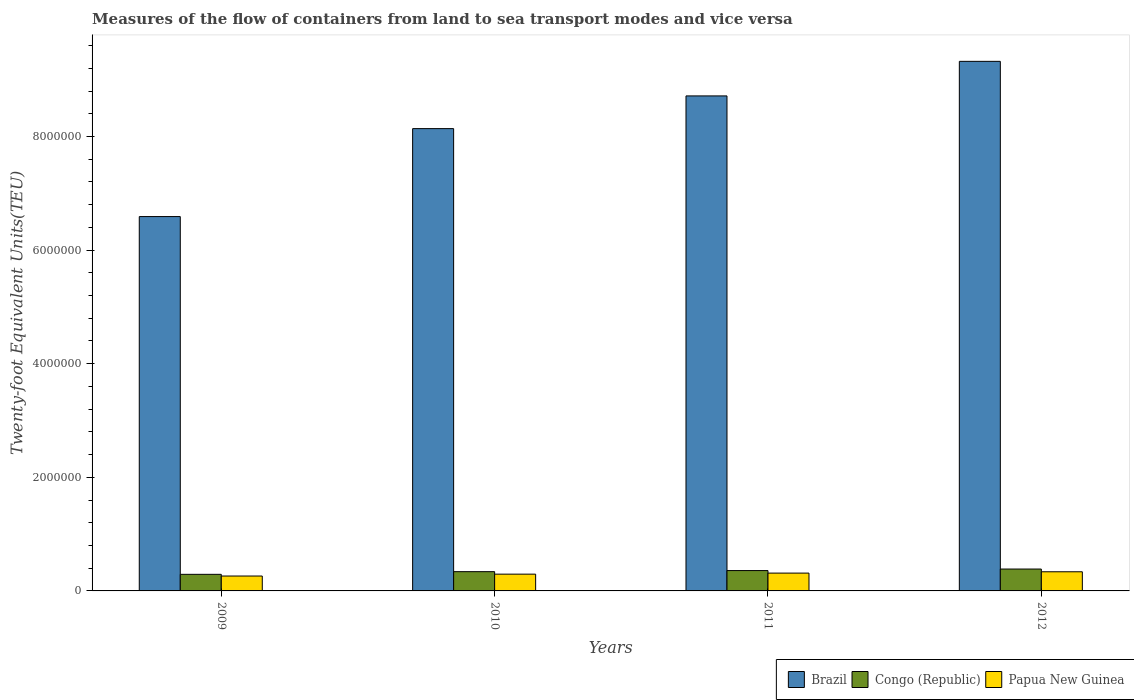How many bars are there on the 1st tick from the left?
Your response must be concise. 3. How many bars are there on the 3rd tick from the right?
Ensure brevity in your answer.  3. What is the label of the 2nd group of bars from the left?
Make the answer very short. 2010. What is the container port traffic in Congo (Republic) in 2009?
Provide a short and direct response. 2.92e+05. Across all years, what is the maximum container port traffic in Congo (Republic)?
Your answer should be compact. 3.85e+05. Across all years, what is the minimum container port traffic in Papua New Guinea?
Keep it short and to the point. 2.62e+05. What is the total container port traffic in Papua New Guinea in the graph?
Offer a terse response. 1.21e+06. What is the difference between the container port traffic in Papua New Guinea in 2010 and that in 2012?
Offer a terse response. -4.18e+04. What is the difference between the container port traffic in Brazil in 2011 and the container port traffic in Congo (Republic) in 2012?
Give a very brief answer. 8.33e+06. What is the average container port traffic in Papua New Guinea per year?
Offer a very short reply. 3.02e+05. In the year 2011, what is the difference between the container port traffic in Brazil and container port traffic in Congo (Republic)?
Offer a terse response. 8.36e+06. In how many years, is the container port traffic in Brazil greater than 2000000 TEU?
Provide a short and direct response. 4. What is the ratio of the container port traffic in Congo (Republic) in 2010 to that in 2011?
Your answer should be compact. 0.95. Is the container port traffic in Papua New Guinea in 2009 less than that in 2012?
Give a very brief answer. Yes. What is the difference between the highest and the second highest container port traffic in Brazil?
Ensure brevity in your answer.  6.08e+05. What is the difference between the highest and the lowest container port traffic in Congo (Republic)?
Offer a very short reply. 9.32e+04. Is the sum of the container port traffic in Papua New Guinea in 2011 and 2012 greater than the maximum container port traffic in Brazil across all years?
Your response must be concise. No. What does the 1st bar from the left in 2012 represents?
Give a very brief answer. Brazil. What does the 1st bar from the right in 2009 represents?
Give a very brief answer. Papua New Guinea. Is it the case that in every year, the sum of the container port traffic in Brazil and container port traffic in Papua New Guinea is greater than the container port traffic in Congo (Republic)?
Offer a very short reply. Yes. How many bars are there?
Offer a terse response. 12. What is the difference between two consecutive major ticks on the Y-axis?
Your answer should be very brief. 2.00e+06. How many legend labels are there?
Give a very brief answer. 3. What is the title of the graph?
Provide a succinct answer. Measures of the flow of containers from land to sea transport modes and vice versa. What is the label or title of the Y-axis?
Offer a terse response. Twenty-foot Equivalent Units(TEU). What is the Twenty-foot Equivalent Units(TEU) of Brazil in 2009?
Make the answer very short. 6.59e+06. What is the Twenty-foot Equivalent Units(TEU) of Congo (Republic) in 2009?
Your answer should be very brief. 2.92e+05. What is the Twenty-foot Equivalent Units(TEU) of Papua New Guinea in 2009?
Make the answer very short. 2.62e+05. What is the Twenty-foot Equivalent Units(TEU) in Brazil in 2010?
Ensure brevity in your answer.  8.14e+06. What is the Twenty-foot Equivalent Units(TEU) of Congo (Republic) in 2010?
Your answer should be compact. 3.39e+05. What is the Twenty-foot Equivalent Units(TEU) of Papua New Guinea in 2010?
Give a very brief answer. 2.95e+05. What is the Twenty-foot Equivalent Units(TEU) of Brazil in 2011?
Give a very brief answer. 8.71e+06. What is the Twenty-foot Equivalent Units(TEU) of Congo (Republic) in 2011?
Ensure brevity in your answer.  3.58e+05. What is the Twenty-foot Equivalent Units(TEU) in Papua New Guinea in 2011?
Provide a short and direct response. 3.14e+05. What is the Twenty-foot Equivalent Units(TEU) of Brazil in 2012?
Your answer should be compact. 9.32e+06. What is the Twenty-foot Equivalent Units(TEU) of Congo (Republic) in 2012?
Provide a succinct answer. 3.85e+05. What is the Twenty-foot Equivalent Units(TEU) of Papua New Guinea in 2012?
Make the answer very short. 3.37e+05. Across all years, what is the maximum Twenty-foot Equivalent Units(TEU) of Brazil?
Make the answer very short. 9.32e+06. Across all years, what is the maximum Twenty-foot Equivalent Units(TEU) in Congo (Republic)?
Keep it short and to the point. 3.85e+05. Across all years, what is the maximum Twenty-foot Equivalent Units(TEU) in Papua New Guinea?
Your answer should be very brief. 3.37e+05. Across all years, what is the minimum Twenty-foot Equivalent Units(TEU) in Brazil?
Make the answer very short. 6.59e+06. Across all years, what is the minimum Twenty-foot Equivalent Units(TEU) in Congo (Republic)?
Your response must be concise. 2.92e+05. Across all years, what is the minimum Twenty-foot Equivalent Units(TEU) of Papua New Guinea?
Your answer should be very brief. 2.62e+05. What is the total Twenty-foot Equivalent Units(TEU) in Brazil in the graph?
Keep it short and to the point. 3.28e+07. What is the total Twenty-foot Equivalent Units(TEU) in Congo (Republic) in the graph?
Provide a short and direct response. 1.37e+06. What is the total Twenty-foot Equivalent Units(TEU) of Papua New Guinea in the graph?
Give a very brief answer. 1.21e+06. What is the difference between the Twenty-foot Equivalent Units(TEU) of Brazil in 2009 and that in 2010?
Offer a very short reply. -1.55e+06. What is the difference between the Twenty-foot Equivalent Units(TEU) of Congo (Republic) in 2009 and that in 2010?
Provide a short and direct response. -4.70e+04. What is the difference between the Twenty-foot Equivalent Units(TEU) in Papua New Guinea in 2009 and that in 2010?
Provide a short and direct response. -3.31e+04. What is the difference between the Twenty-foot Equivalent Units(TEU) in Brazil in 2009 and that in 2011?
Your answer should be very brief. -2.12e+06. What is the difference between the Twenty-foot Equivalent Units(TEU) of Congo (Republic) in 2009 and that in 2011?
Provide a short and direct response. -6.63e+04. What is the difference between the Twenty-foot Equivalent Units(TEU) of Papua New Guinea in 2009 and that in 2011?
Offer a terse response. -5.14e+04. What is the difference between the Twenty-foot Equivalent Units(TEU) of Brazil in 2009 and that in 2012?
Give a very brief answer. -2.73e+06. What is the difference between the Twenty-foot Equivalent Units(TEU) of Congo (Republic) in 2009 and that in 2012?
Ensure brevity in your answer.  -9.32e+04. What is the difference between the Twenty-foot Equivalent Units(TEU) of Papua New Guinea in 2009 and that in 2012?
Offer a very short reply. -7.49e+04. What is the difference between the Twenty-foot Equivalent Units(TEU) of Brazil in 2010 and that in 2011?
Make the answer very short. -5.76e+05. What is the difference between the Twenty-foot Equivalent Units(TEU) of Congo (Republic) in 2010 and that in 2011?
Your response must be concise. -1.93e+04. What is the difference between the Twenty-foot Equivalent Units(TEU) of Papua New Guinea in 2010 and that in 2011?
Offer a very short reply. -1.83e+04. What is the difference between the Twenty-foot Equivalent Units(TEU) in Brazil in 2010 and that in 2012?
Offer a very short reply. -1.18e+06. What is the difference between the Twenty-foot Equivalent Units(TEU) in Congo (Republic) in 2010 and that in 2012?
Keep it short and to the point. -4.62e+04. What is the difference between the Twenty-foot Equivalent Units(TEU) of Papua New Guinea in 2010 and that in 2012?
Offer a terse response. -4.18e+04. What is the difference between the Twenty-foot Equivalent Units(TEU) of Brazil in 2011 and that in 2012?
Ensure brevity in your answer.  -6.08e+05. What is the difference between the Twenty-foot Equivalent Units(TEU) in Congo (Republic) in 2011 and that in 2012?
Offer a terse response. -2.69e+04. What is the difference between the Twenty-foot Equivalent Units(TEU) of Papua New Guinea in 2011 and that in 2012?
Your answer should be very brief. -2.35e+04. What is the difference between the Twenty-foot Equivalent Units(TEU) of Brazil in 2009 and the Twenty-foot Equivalent Units(TEU) of Congo (Republic) in 2010?
Your answer should be very brief. 6.25e+06. What is the difference between the Twenty-foot Equivalent Units(TEU) in Brazil in 2009 and the Twenty-foot Equivalent Units(TEU) in Papua New Guinea in 2010?
Your response must be concise. 6.30e+06. What is the difference between the Twenty-foot Equivalent Units(TEU) of Congo (Republic) in 2009 and the Twenty-foot Equivalent Units(TEU) of Papua New Guinea in 2010?
Keep it short and to the point. -3368.95. What is the difference between the Twenty-foot Equivalent Units(TEU) in Brazil in 2009 and the Twenty-foot Equivalent Units(TEU) in Congo (Republic) in 2011?
Make the answer very short. 6.23e+06. What is the difference between the Twenty-foot Equivalent Units(TEU) in Brazil in 2009 and the Twenty-foot Equivalent Units(TEU) in Papua New Guinea in 2011?
Offer a terse response. 6.28e+06. What is the difference between the Twenty-foot Equivalent Units(TEU) in Congo (Republic) in 2009 and the Twenty-foot Equivalent Units(TEU) in Papua New Guinea in 2011?
Your answer should be compact. -2.17e+04. What is the difference between the Twenty-foot Equivalent Units(TEU) of Brazil in 2009 and the Twenty-foot Equivalent Units(TEU) of Congo (Republic) in 2012?
Provide a short and direct response. 6.21e+06. What is the difference between the Twenty-foot Equivalent Units(TEU) in Brazil in 2009 and the Twenty-foot Equivalent Units(TEU) in Papua New Guinea in 2012?
Make the answer very short. 6.25e+06. What is the difference between the Twenty-foot Equivalent Units(TEU) in Congo (Republic) in 2009 and the Twenty-foot Equivalent Units(TEU) in Papua New Guinea in 2012?
Ensure brevity in your answer.  -4.52e+04. What is the difference between the Twenty-foot Equivalent Units(TEU) of Brazil in 2010 and the Twenty-foot Equivalent Units(TEU) of Congo (Republic) in 2011?
Keep it short and to the point. 7.78e+06. What is the difference between the Twenty-foot Equivalent Units(TEU) in Brazil in 2010 and the Twenty-foot Equivalent Units(TEU) in Papua New Guinea in 2011?
Give a very brief answer. 7.83e+06. What is the difference between the Twenty-foot Equivalent Units(TEU) of Congo (Republic) in 2010 and the Twenty-foot Equivalent Units(TEU) of Papua New Guinea in 2011?
Your answer should be very brief. 2.53e+04. What is the difference between the Twenty-foot Equivalent Units(TEU) of Brazil in 2010 and the Twenty-foot Equivalent Units(TEU) of Congo (Republic) in 2012?
Make the answer very short. 7.75e+06. What is the difference between the Twenty-foot Equivalent Units(TEU) of Brazil in 2010 and the Twenty-foot Equivalent Units(TEU) of Papua New Guinea in 2012?
Give a very brief answer. 7.80e+06. What is the difference between the Twenty-foot Equivalent Units(TEU) of Congo (Republic) in 2010 and the Twenty-foot Equivalent Units(TEU) of Papua New Guinea in 2012?
Your answer should be very brief. 1798.38. What is the difference between the Twenty-foot Equivalent Units(TEU) in Brazil in 2011 and the Twenty-foot Equivalent Units(TEU) in Congo (Republic) in 2012?
Offer a very short reply. 8.33e+06. What is the difference between the Twenty-foot Equivalent Units(TEU) in Brazil in 2011 and the Twenty-foot Equivalent Units(TEU) in Papua New Guinea in 2012?
Ensure brevity in your answer.  8.38e+06. What is the difference between the Twenty-foot Equivalent Units(TEU) of Congo (Republic) in 2011 and the Twenty-foot Equivalent Units(TEU) of Papua New Guinea in 2012?
Offer a very short reply. 2.11e+04. What is the average Twenty-foot Equivalent Units(TEU) of Brazil per year?
Provide a short and direct response. 8.19e+06. What is the average Twenty-foot Equivalent Units(TEU) in Congo (Republic) per year?
Your answer should be very brief. 3.44e+05. What is the average Twenty-foot Equivalent Units(TEU) of Papua New Guinea per year?
Offer a very short reply. 3.02e+05. In the year 2009, what is the difference between the Twenty-foot Equivalent Units(TEU) of Brazil and Twenty-foot Equivalent Units(TEU) of Congo (Republic)?
Give a very brief answer. 6.30e+06. In the year 2009, what is the difference between the Twenty-foot Equivalent Units(TEU) of Brazil and Twenty-foot Equivalent Units(TEU) of Papua New Guinea?
Your response must be concise. 6.33e+06. In the year 2009, what is the difference between the Twenty-foot Equivalent Units(TEU) of Congo (Republic) and Twenty-foot Equivalent Units(TEU) of Papua New Guinea?
Your answer should be very brief. 2.97e+04. In the year 2010, what is the difference between the Twenty-foot Equivalent Units(TEU) of Brazil and Twenty-foot Equivalent Units(TEU) of Congo (Republic)?
Offer a very short reply. 7.80e+06. In the year 2010, what is the difference between the Twenty-foot Equivalent Units(TEU) of Brazil and Twenty-foot Equivalent Units(TEU) of Papua New Guinea?
Ensure brevity in your answer.  7.84e+06. In the year 2010, what is the difference between the Twenty-foot Equivalent Units(TEU) of Congo (Republic) and Twenty-foot Equivalent Units(TEU) of Papua New Guinea?
Your answer should be very brief. 4.36e+04. In the year 2011, what is the difference between the Twenty-foot Equivalent Units(TEU) in Brazil and Twenty-foot Equivalent Units(TEU) in Congo (Republic)?
Make the answer very short. 8.36e+06. In the year 2011, what is the difference between the Twenty-foot Equivalent Units(TEU) in Brazil and Twenty-foot Equivalent Units(TEU) in Papua New Guinea?
Make the answer very short. 8.40e+06. In the year 2011, what is the difference between the Twenty-foot Equivalent Units(TEU) of Congo (Republic) and Twenty-foot Equivalent Units(TEU) of Papua New Guinea?
Make the answer very short. 4.46e+04. In the year 2012, what is the difference between the Twenty-foot Equivalent Units(TEU) of Brazil and Twenty-foot Equivalent Units(TEU) of Congo (Republic)?
Your answer should be very brief. 8.94e+06. In the year 2012, what is the difference between the Twenty-foot Equivalent Units(TEU) of Brazil and Twenty-foot Equivalent Units(TEU) of Papua New Guinea?
Keep it short and to the point. 8.99e+06. In the year 2012, what is the difference between the Twenty-foot Equivalent Units(TEU) in Congo (Republic) and Twenty-foot Equivalent Units(TEU) in Papua New Guinea?
Make the answer very short. 4.80e+04. What is the ratio of the Twenty-foot Equivalent Units(TEU) in Brazil in 2009 to that in 2010?
Make the answer very short. 0.81. What is the ratio of the Twenty-foot Equivalent Units(TEU) in Congo (Republic) in 2009 to that in 2010?
Give a very brief answer. 0.86. What is the ratio of the Twenty-foot Equivalent Units(TEU) of Papua New Guinea in 2009 to that in 2010?
Keep it short and to the point. 0.89. What is the ratio of the Twenty-foot Equivalent Units(TEU) of Brazil in 2009 to that in 2011?
Your answer should be very brief. 0.76. What is the ratio of the Twenty-foot Equivalent Units(TEU) in Congo (Republic) in 2009 to that in 2011?
Offer a terse response. 0.81. What is the ratio of the Twenty-foot Equivalent Units(TEU) of Papua New Guinea in 2009 to that in 2011?
Your answer should be very brief. 0.84. What is the ratio of the Twenty-foot Equivalent Units(TEU) in Brazil in 2009 to that in 2012?
Keep it short and to the point. 0.71. What is the ratio of the Twenty-foot Equivalent Units(TEU) in Congo (Republic) in 2009 to that in 2012?
Your answer should be compact. 0.76. What is the ratio of the Twenty-foot Equivalent Units(TEU) in Papua New Guinea in 2009 to that in 2012?
Your answer should be compact. 0.78. What is the ratio of the Twenty-foot Equivalent Units(TEU) in Brazil in 2010 to that in 2011?
Your response must be concise. 0.93. What is the ratio of the Twenty-foot Equivalent Units(TEU) of Congo (Republic) in 2010 to that in 2011?
Your response must be concise. 0.95. What is the ratio of the Twenty-foot Equivalent Units(TEU) of Papua New Guinea in 2010 to that in 2011?
Your answer should be compact. 0.94. What is the ratio of the Twenty-foot Equivalent Units(TEU) of Brazil in 2010 to that in 2012?
Your answer should be very brief. 0.87. What is the ratio of the Twenty-foot Equivalent Units(TEU) of Congo (Republic) in 2010 to that in 2012?
Offer a terse response. 0.88. What is the ratio of the Twenty-foot Equivalent Units(TEU) in Papua New Guinea in 2010 to that in 2012?
Your answer should be very brief. 0.88. What is the ratio of the Twenty-foot Equivalent Units(TEU) in Brazil in 2011 to that in 2012?
Your answer should be compact. 0.93. What is the ratio of the Twenty-foot Equivalent Units(TEU) of Congo (Republic) in 2011 to that in 2012?
Your answer should be very brief. 0.93. What is the ratio of the Twenty-foot Equivalent Units(TEU) in Papua New Guinea in 2011 to that in 2012?
Offer a very short reply. 0.93. What is the difference between the highest and the second highest Twenty-foot Equivalent Units(TEU) in Brazil?
Your response must be concise. 6.08e+05. What is the difference between the highest and the second highest Twenty-foot Equivalent Units(TEU) of Congo (Republic)?
Give a very brief answer. 2.69e+04. What is the difference between the highest and the second highest Twenty-foot Equivalent Units(TEU) in Papua New Guinea?
Provide a succinct answer. 2.35e+04. What is the difference between the highest and the lowest Twenty-foot Equivalent Units(TEU) of Brazil?
Your response must be concise. 2.73e+06. What is the difference between the highest and the lowest Twenty-foot Equivalent Units(TEU) in Congo (Republic)?
Your answer should be compact. 9.32e+04. What is the difference between the highest and the lowest Twenty-foot Equivalent Units(TEU) in Papua New Guinea?
Make the answer very short. 7.49e+04. 